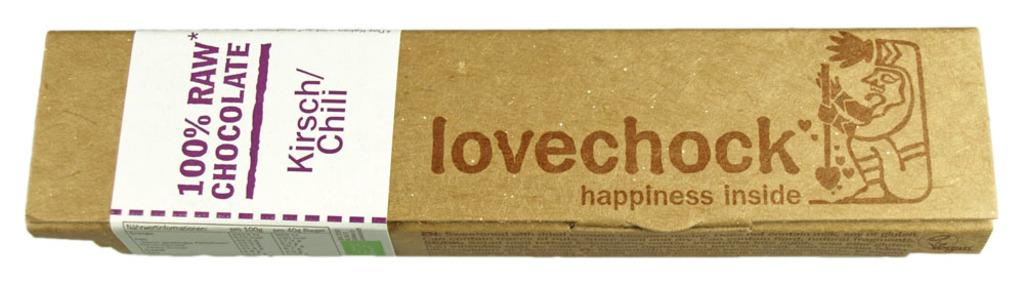<image>
Give a short and clear explanation of the subsequent image. the word love that is on a brown box 